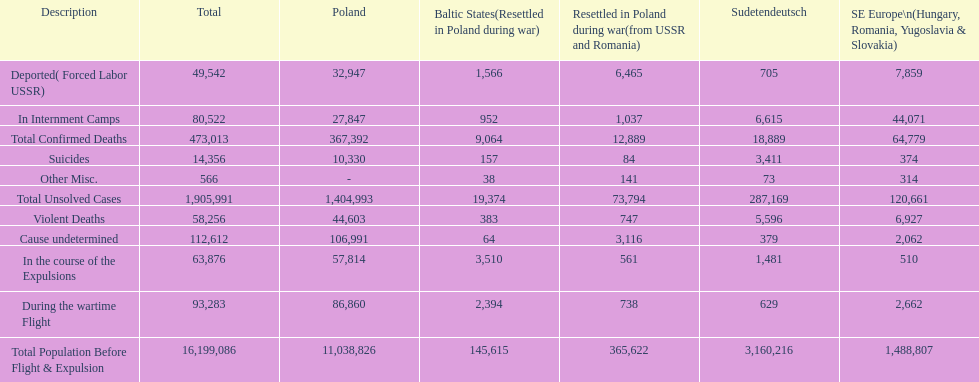How many reasons led to over 50,000 verified fatalities? 5. 